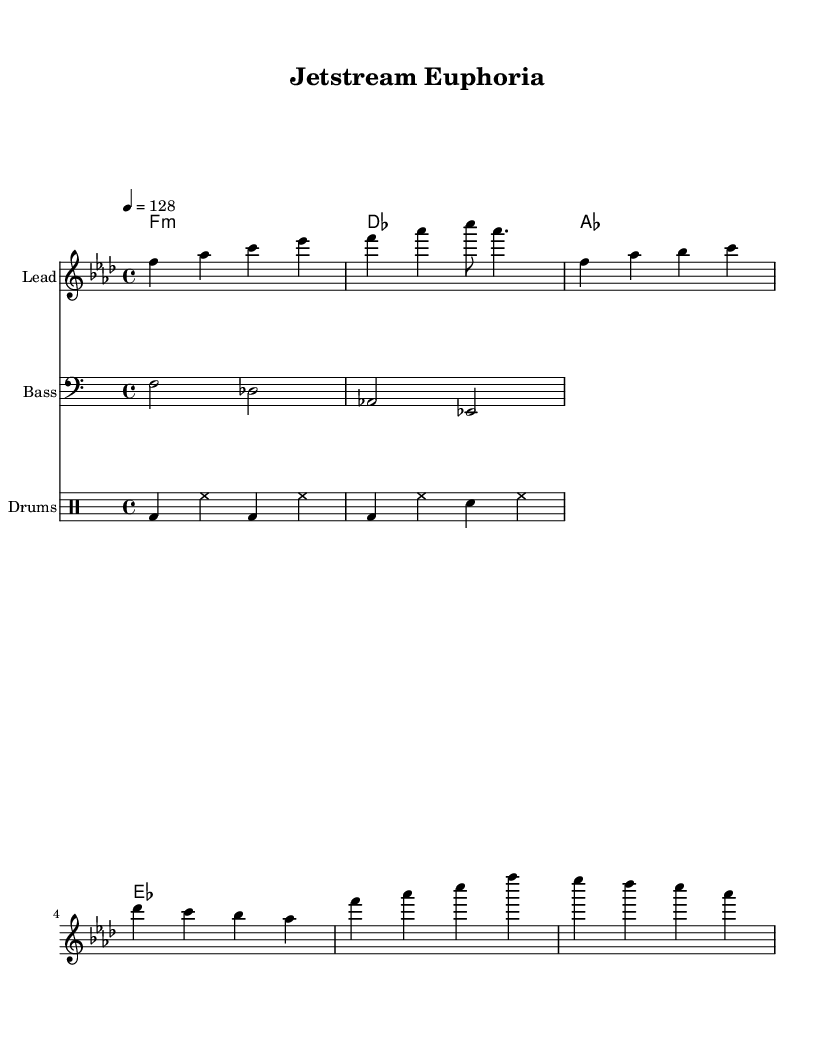What is the key signature of this music? The key signature appears in the beginning of the sheet music. The 'f' key is indicated, which shows that there are four flats (B♭, E♭, A♭, D♭). This means the key signature is F minor.
Answer: F minor What is the time signature of this piece? The time signature is shown just after the key signature. It is indicated as "4/4," which means there are four beats in a measure and the quarter note receives one beat.
Answer: 4/4 What tempo marking is used in this music? The tempo marking is found near the top of the sheet music. It is indicated as "4 = 128," meaning the quarter note gets a tempo of 128 beats per minute.
Answer: 128 How many measures are in the melody? By counting the measures in the melody section, we see that there are 9 measures in total. Each line of music generally contains 4 measures in the format used here.
Answer: 9 What is the main instrumental section that carries the melody? In the score, the first staff labeled "Lead" is responsible for the melody, as indicated by the instrumental name above that staff.
Answer: Lead What type of chord progression is indicated in the harmonies section? The chord symbols show a progression where the first chord is F minor, followed by des (D♭ major), then A♭ major, and ending with E♭ major. This provides a progression typical in electronic music, emphasizing a continuous harmonic movement.
Answer: F minor, D♭, A♭, E♭ 